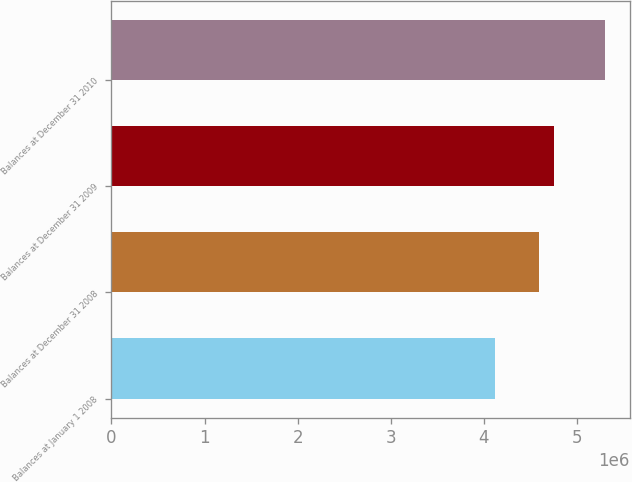Convert chart to OTSL. <chart><loc_0><loc_0><loc_500><loc_500><bar_chart><fcel>Balances at January 1 2008<fcel>Balances at December 31 2008<fcel>Balances at December 31 2009<fcel>Balances at December 31 2010<nl><fcel>4.11488e+06<fcel>4.59253e+06<fcel>4.75495e+06<fcel>5.30175e+06<nl></chart> 